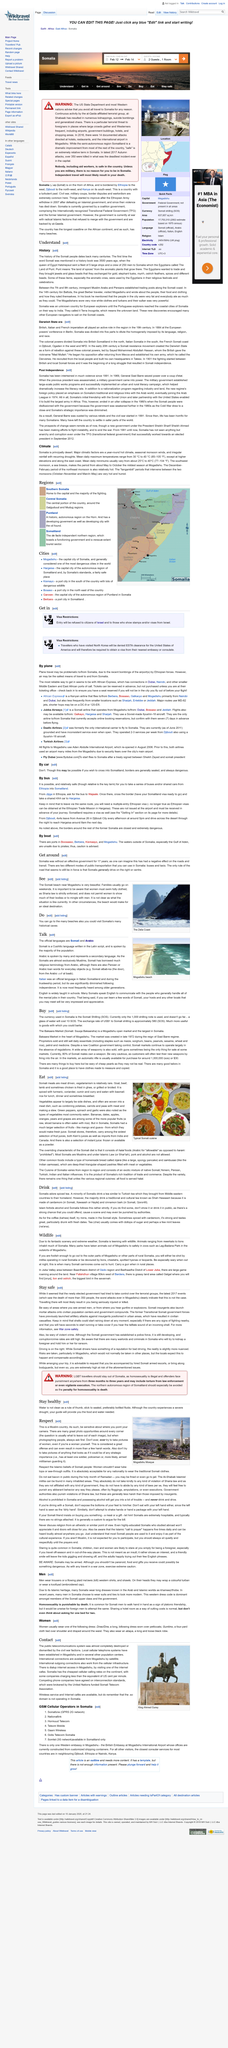Identify some key points in this picture. Somali is a Cushitic language written in the Latin script that is spoken by Somalis. The Somali and Arabic languages are the official languages. The above picture was taken at Mogadishu beach. 